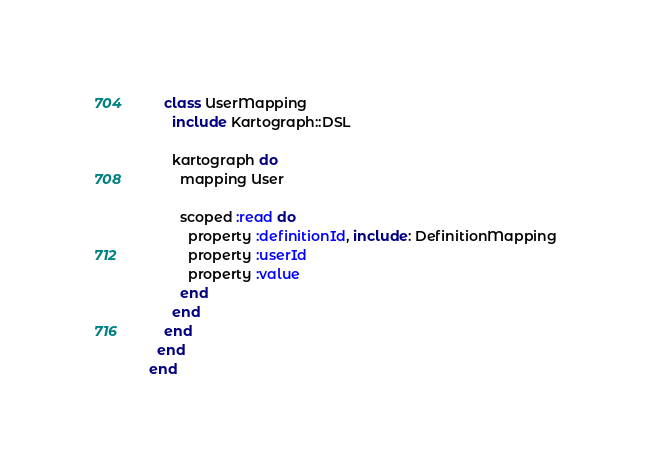Convert code to text. <code><loc_0><loc_0><loc_500><loc_500><_Ruby_>    class UserMapping
      include Kartograph::DSL

      kartograph do
        mapping User

        scoped :read do
          property :definitionId, include: DefinitionMapping
          property :userId
          property :value
        end
      end
    end
  end
end
</code> 